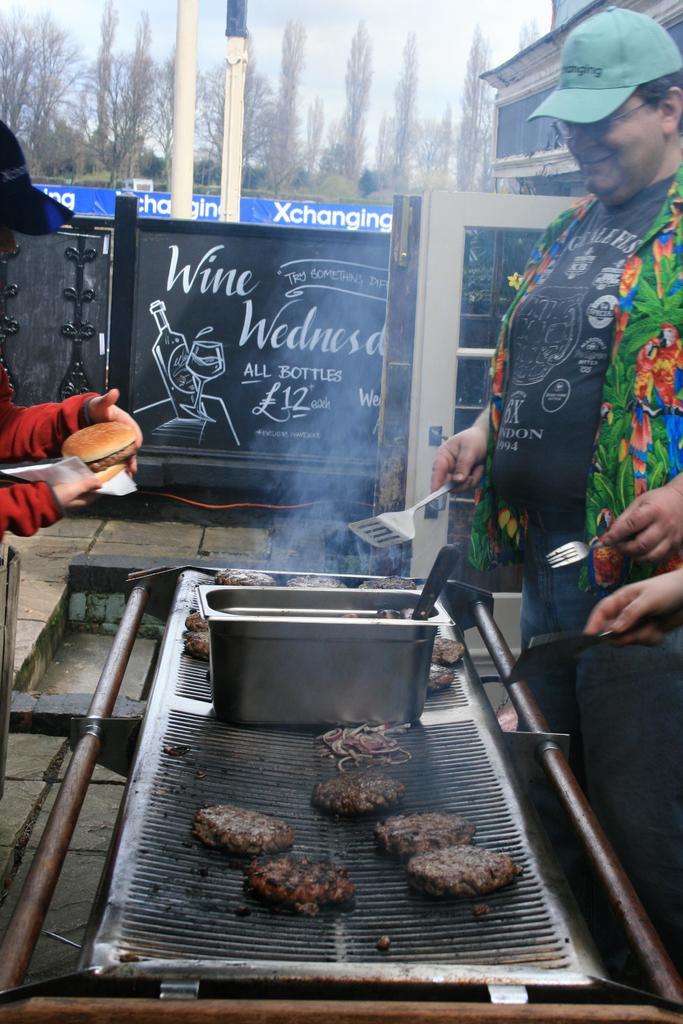What day is wine discounted on?
Ensure brevity in your answer.  Wednesday. What is the word in on the right in white on the blue banner?
Your answer should be compact. Xchanging. 